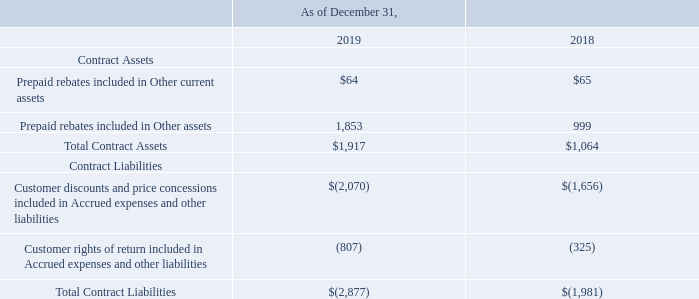NOTES TO CONSOLIDATED FINANCIAL STATEMENTS (in thousands, except for share and per share data)
Contract Assets and Liabilities
Contract assets and liabilities included in our Consolidated Balance Sheets are as follows:
During the twelve months ended December 31, 2019, we recognized revenues of $256 that was included in contract liabilities at the beginning of the period.
Which years does the table provide information for the company's Contract assets and liabilities? 2019, 2018. What were the Prepaid rebates included in Other current assets in 2019?
Answer scale should be: thousand. 64. What were the Prepaid rebates included in Other assets in 2018?
Answer scale should be: thousand. 999. How many years did total contract assets exceed $1,500 thousand? 2019
Answer: 1. What was the change in the Prepaid rebates included in Other assets between 2018 and 2019?
Answer scale should be: thousand. 1,853-999
Answer: 854. What was the percentage change in total contract liabilities between 2018 and 2019?
Answer scale should be: percent. (-2,877-(-1,981))/-1,981
Answer: 45.23. 